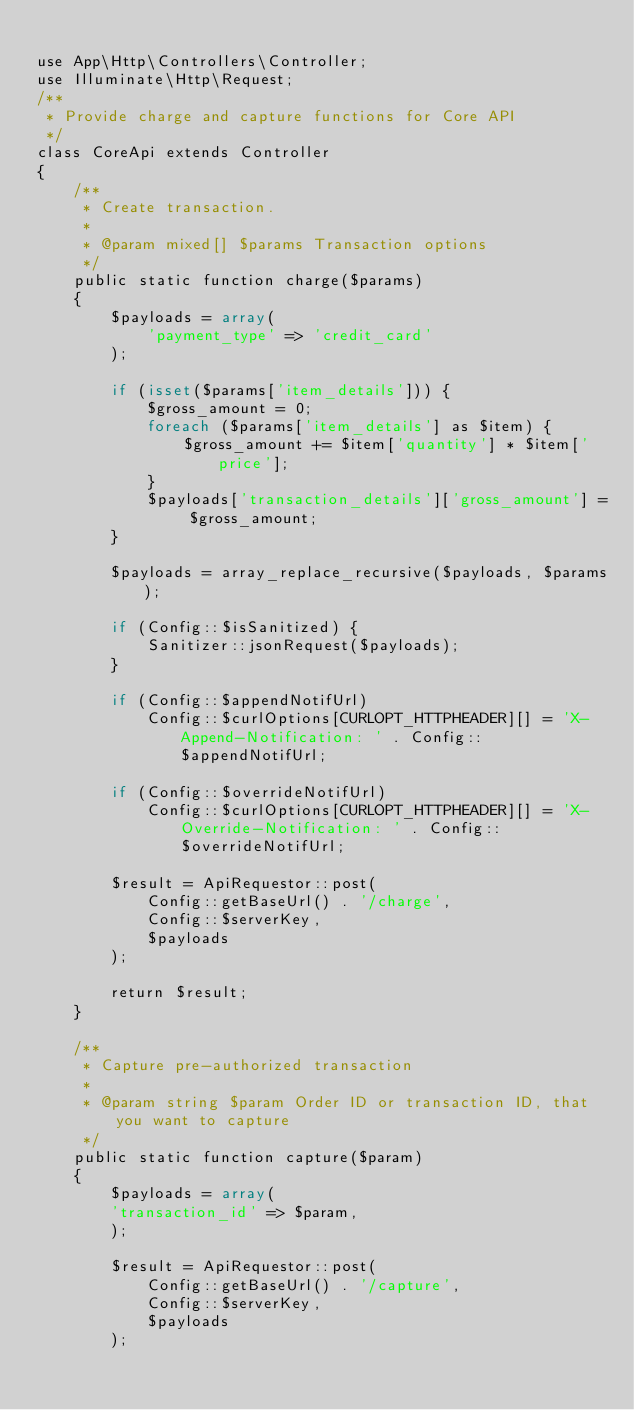<code> <loc_0><loc_0><loc_500><loc_500><_PHP_>
use App\Http\Controllers\Controller;
use Illuminate\Http\Request;
/**
 * Provide charge and capture functions for Core API
 */
class CoreApi extends Controller
{
    /**
     * Create transaction.
     *
     * @param mixed[] $params Transaction options
     */
    public static function charge($params)
    {
        $payloads = array(
            'payment_type' => 'credit_card'
        );

        if (isset($params['item_details'])) {
            $gross_amount = 0;
            foreach ($params['item_details'] as $item) {
                $gross_amount += $item['quantity'] * $item['price'];
            }
            $payloads['transaction_details']['gross_amount'] = $gross_amount;
        }

        $payloads = array_replace_recursive($payloads, $params);

        if (Config::$isSanitized) {
            Sanitizer::jsonRequest($payloads);
        }

        if (Config::$appendNotifUrl)
            Config::$curlOptions[CURLOPT_HTTPHEADER][] = 'X-Append-Notification: ' . Config::$appendNotifUrl;

        if (Config::$overrideNotifUrl)
            Config::$curlOptions[CURLOPT_HTTPHEADER][] = 'X-Override-Notification: ' . Config::$overrideNotifUrl;

        $result = ApiRequestor::post(
            Config::getBaseUrl() . '/charge',
            Config::$serverKey,
            $payloads
        );

        return $result;
    }

    /**
     * Capture pre-authorized transaction
     *
     * @param string $param Order ID or transaction ID, that you want to capture
     */
    public static function capture($param)
    {
        $payloads = array(
        'transaction_id' => $param,
        );

        $result = ApiRequestor::post(
            Config::getBaseUrl() . '/capture',
            Config::$serverKey,
            $payloads
        );
</code> 